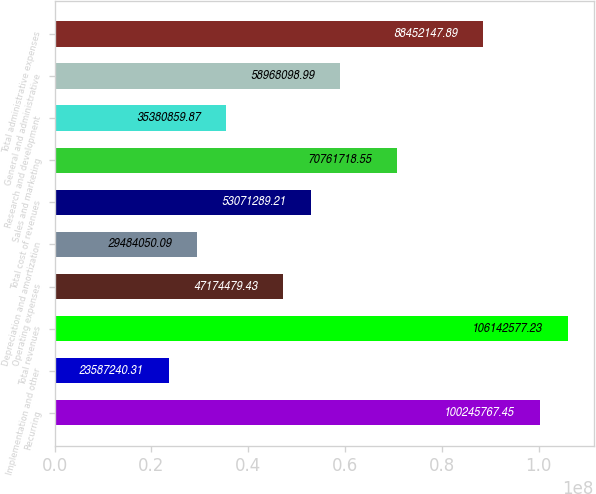Convert chart to OTSL. <chart><loc_0><loc_0><loc_500><loc_500><bar_chart><fcel>Recurring<fcel>Implementation and other<fcel>Total revenues<fcel>Operating expenses<fcel>Depreciation and amortization<fcel>Total cost of revenues<fcel>Sales and marketing<fcel>Research and development<fcel>General and administrative<fcel>Total administrative expenses<nl><fcel>1.00246e+08<fcel>2.35872e+07<fcel>1.06143e+08<fcel>4.71745e+07<fcel>2.94841e+07<fcel>5.30713e+07<fcel>7.07617e+07<fcel>3.53809e+07<fcel>5.89681e+07<fcel>8.84521e+07<nl></chart> 